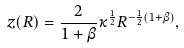Convert formula to latex. <formula><loc_0><loc_0><loc_500><loc_500>z ( R ) = \frac { 2 } { 1 + \beta } \kappa ^ { \frac { 1 } { 2 } } R ^ { - \frac { 1 } { 2 } ( 1 + \beta ) } ,</formula> 